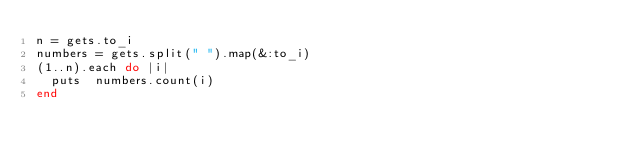Convert code to text. <code><loc_0><loc_0><loc_500><loc_500><_Ruby_>n = gets.to_i
numbers = gets.split(" ").map(&:to_i)
(1..n).each do |i| 
  puts  numbers.count(i)
end

</code> 